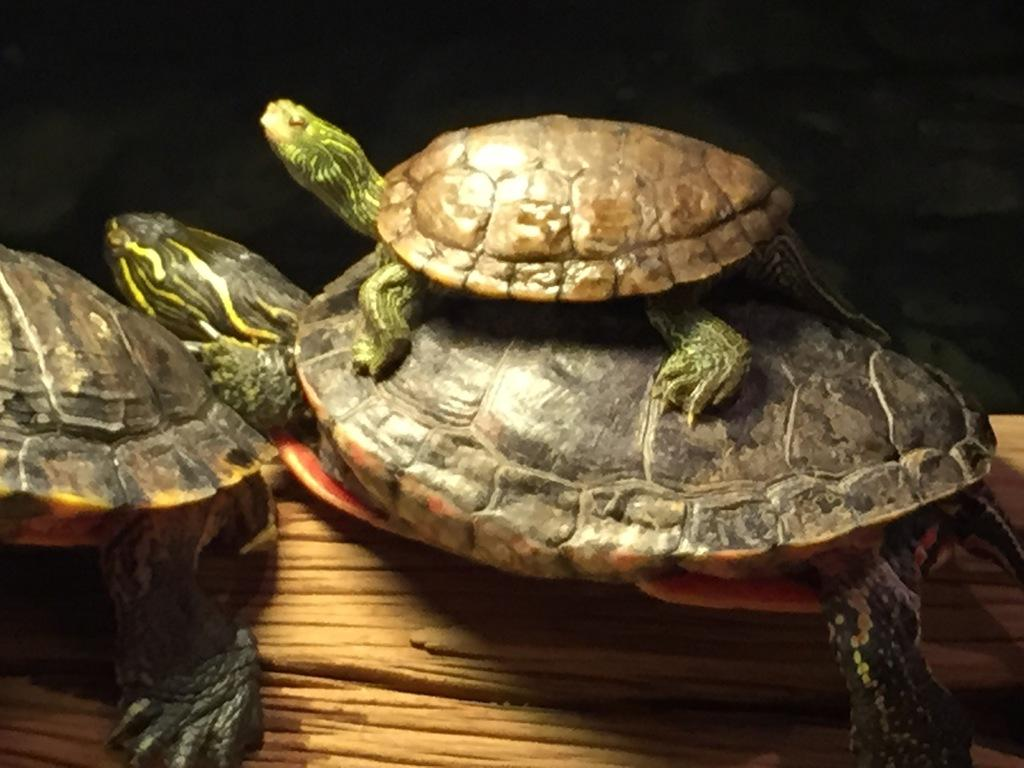What type of animals are in the image? There are tortoises in the image. What surface are the tortoises on? The tortoises are on a wooden surface. What can be observed about the background of the image? The background of the image is dark. What type of crime is being committed in the image? There is no crime being committed in the image; it features tortoises on a wooden surface with a dark background. How is the air quality in the image? The image does not provide any information about the air quality. 